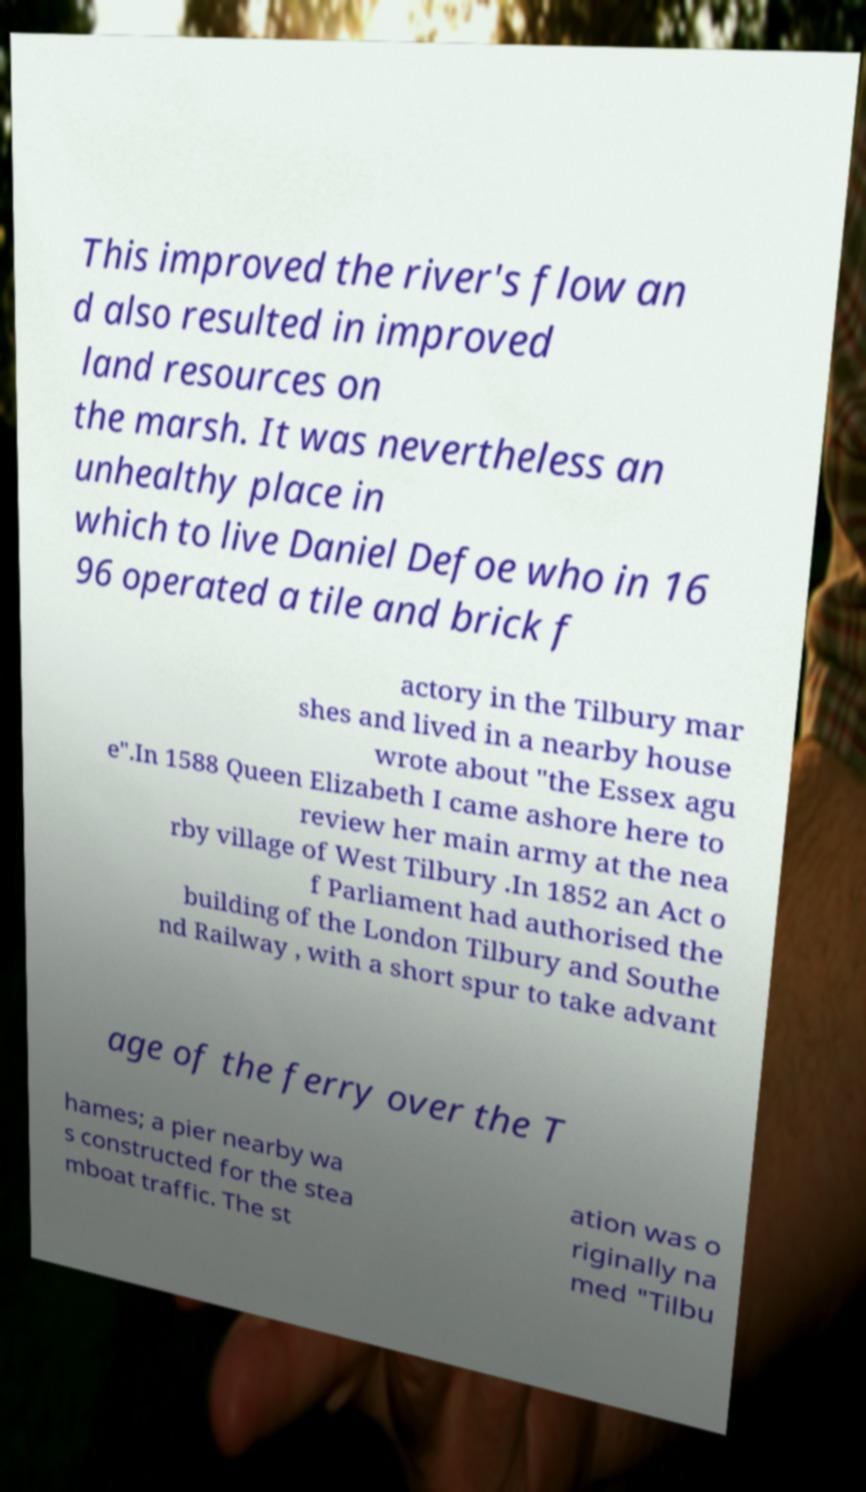For documentation purposes, I need the text within this image transcribed. Could you provide that? This improved the river's flow an d also resulted in improved land resources on the marsh. It was nevertheless an unhealthy place in which to live Daniel Defoe who in 16 96 operated a tile and brick f actory in the Tilbury mar shes and lived in a nearby house wrote about "the Essex agu e".In 1588 Queen Elizabeth I came ashore here to review her main army at the nea rby village of West Tilbury .In 1852 an Act o f Parliament had authorised the building of the London Tilbury and Southe nd Railway , with a short spur to take advant age of the ferry over the T hames; a pier nearby wa s constructed for the stea mboat traffic. The st ation was o riginally na med "Tilbu 